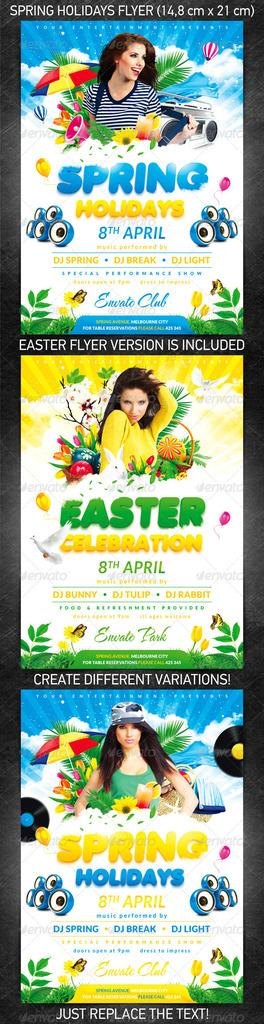<image>
Render a clear and concise summary of the photo. The Spring Holiday advertisement has a lot of color and a model wearing 3 sets of clothes. 